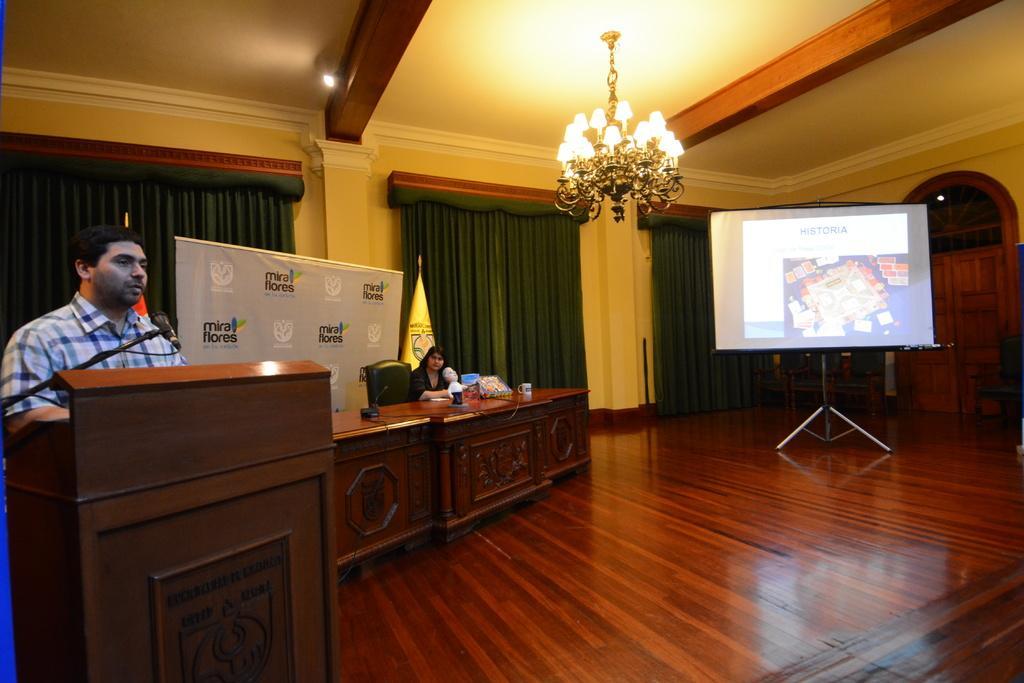In one or two sentences, can you explain what this image depicts? In this picture we can see a man is standing behind the podium and on the left side of the podium there is a microphone with stand and a cable. On the right side of the man there is another person sitting on a chair. In front of the person there is a table and on the table there is a toy, a cup and some objects. On the right side of the table there is a projector screen with a stand. Behind the people there is a banner, a flag, a wall and curtains. At the top there is a chandelier and on the right side of the projector screen there is a chair and a door. 